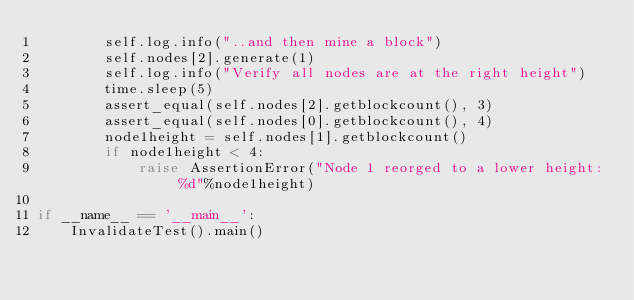Convert code to text. <code><loc_0><loc_0><loc_500><loc_500><_Python_>        self.log.info("..and then mine a block")
        self.nodes[2].generate(1)
        self.log.info("Verify all nodes are at the right height")
        time.sleep(5)
        assert_equal(self.nodes[2].getblockcount(), 3)
        assert_equal(self.nodes[0].getblockcount(), 4)
        node1height = self.nodes[1].getblockcount()
        if node1height < 4:
            raise AssertionError("Node 1 reorged to a lower height: %d"%node1height)

if __name__ == '__main__':
    InvalidateTest().main()
</code> 